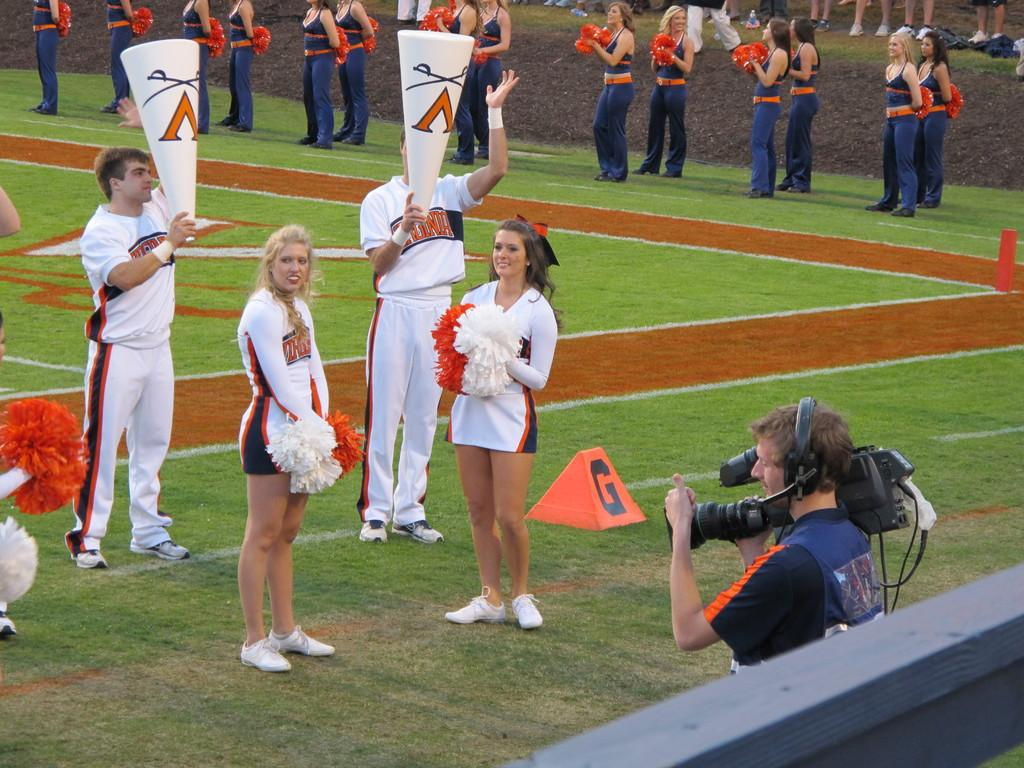<image>
Give a short and clear explanation of the subsequent image. The cheer leaders stand on the field with a red block with the letter G on it. 